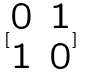<formula> <loc_0><loc_0><loc_500><loc_500>[ \begin{matrix} 0 & 1 \\ 1 & 0 \end{matrix} ]</formula> 